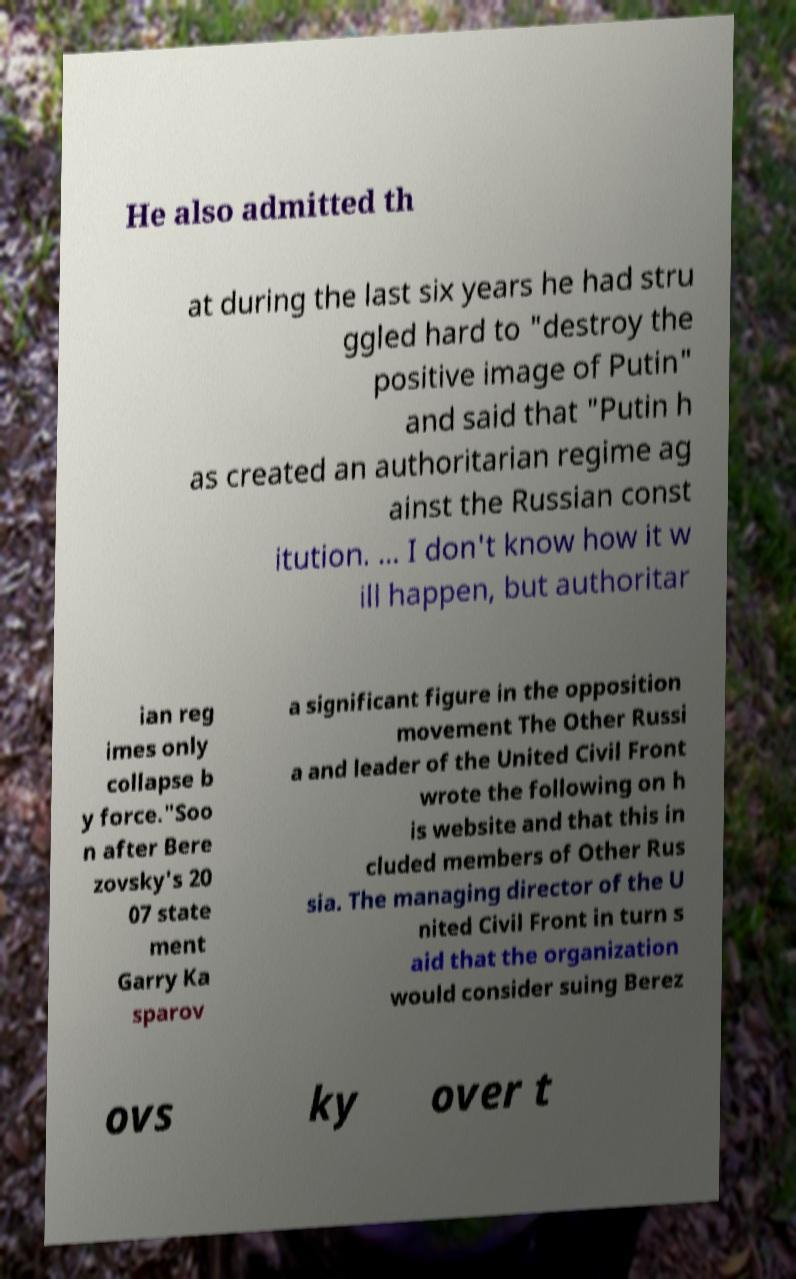There's text embedded in this image that I need extracted. Can you transcribe it verbatim? He also admitted th at during the last six years he had stru ggled hard to "destroy the positive image of Putin" and said that "Putin h as created an authoritarian regime ag ainst the Russian const itution. ... I don't know how it w ill happen, but authoritar ian reg imes only collapse b y force."Soo n after Bere zovsky's 20 07 state ment Garry Ka sparov a significant figure in the opposition movement The Other Russi a and leader of the United Civil Front wrote the following on h is website and that this in cluded members of Other Rus sia. The managing director of the U nited Civil Front in turn s aid that the organization would consider suing Berez ovs ky over t 